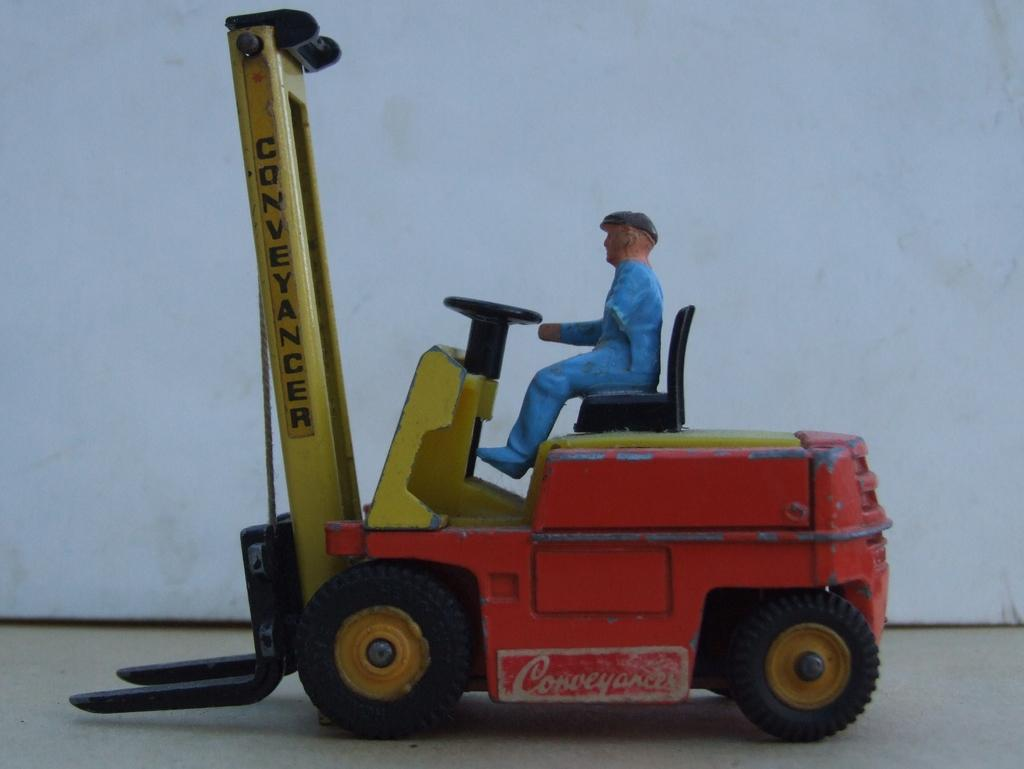What is the main subject of the image? There is a miniature in the image. What color is the background of the image? The background of the image is white. What type of humor can be seen in the miniature in the image? There is no humor present in the miniature in the image; it is simply a miniature. Can you tell me how many basketballs are visible in the image? There are no basketballs present in the image. 